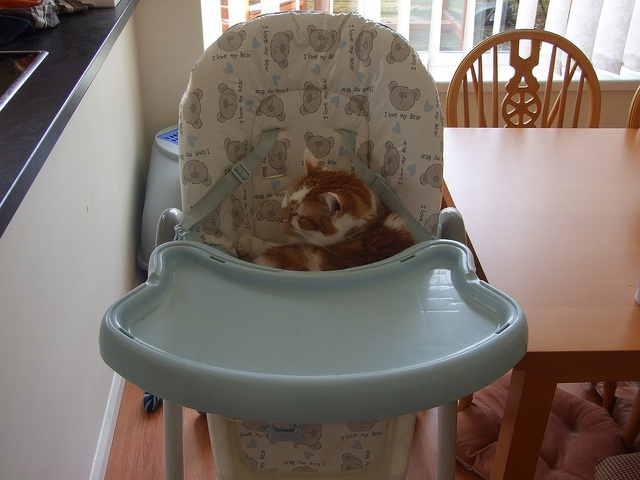Describe the objects in this image and their specific colors. I can see chair in maroon, gray, and black tones, dining table in maroon, darkgray, and lightgray tones, chair in maroon, gray, and white tones, cat in maroon, black, and gray tones, and sink in maroon, black, lavender, and gray tones in this image. 